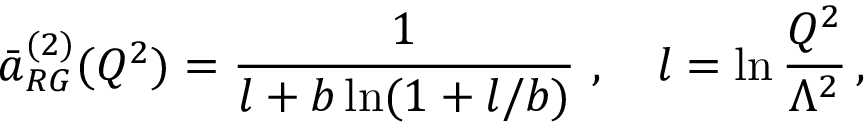Convert formula to latex. <formula><loc_0><loc_0><loc_500><loc_500>\bar { a } _ { R G } ^ { ( 2 ) } ( Q ^ { 2 } ) = \frac { 1 } { l + b \ln ( 1 + l / b ) } , \quad l = \ln \frac { Q ^ { 2 } } { \Lambda ^ { 2 } } \, ,</formula> 